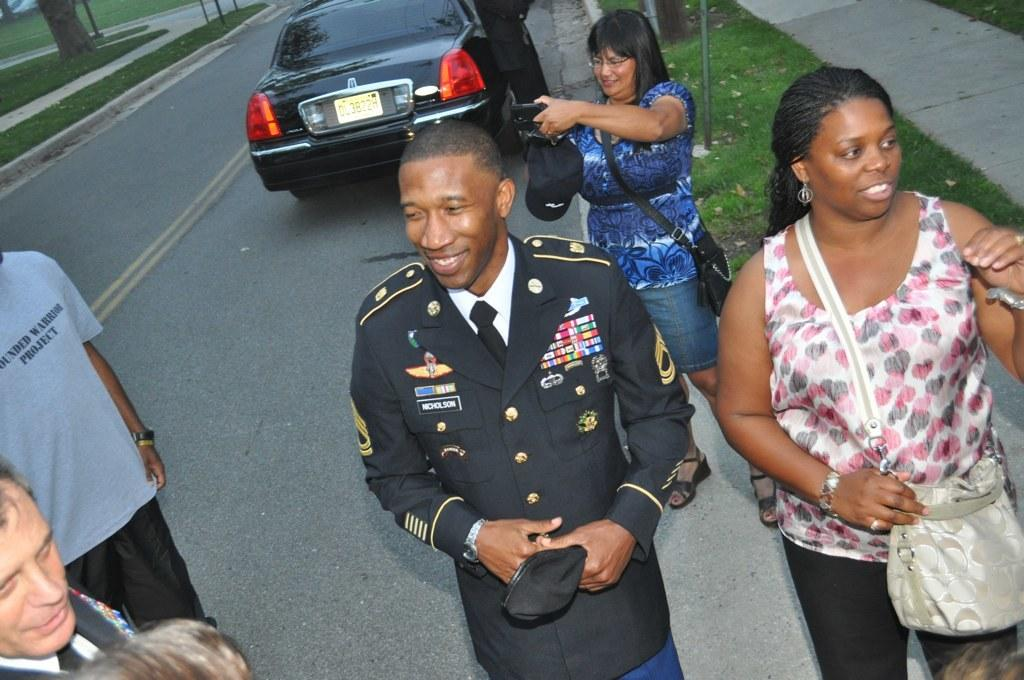What is happening in the image? There is a group of people in the image. Where are the people located? The people are on the road. What can be seen in the background of the image? There is a vehicle visible in the background of the image, and grass is also present. What type of honey is being collected by the people in the image? There is no honey or honey collection activity present in the image. 